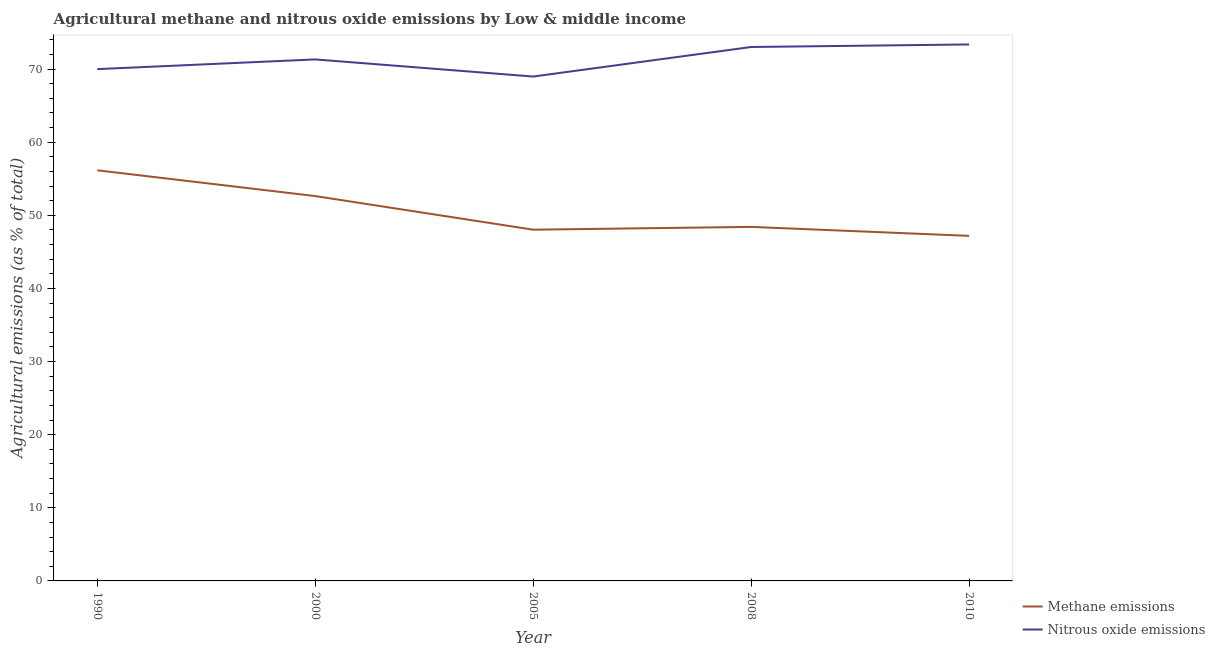How many different coloured lines are there?
Your answer should be very brief. 2. What is the amount of methane emissions in 2000?
Provide a short and direct response. 52.63. Across all years, what is the maximum amount of nitrous oxide emissions?
Ensure brevity in your answer.  73.37. Across all years, what is the minimum amount of methane emissions?
Ensure brevity in your answer.  47.19. What is the total amount of methane emissions in the graph?
Your answer should be very brief. 252.44. What is the difference between the amount of methane emissions in 2008 and that in 2010?
Offer a very short reply. 1.23. What is the difference between the amount of methane emissions in 2008 and the amount of nitrous oxide emissions in 2010?
Give a very brief answer. -24.95. What is the average amount of methane emissions per year?
Keep it short and to the point. 50.49. In the year 2008, what is the difference between the amount of nitrous oxide emissions and amount of methane emissions?
Offer a very short reply. 24.6. In how many years, is the amount of nitrous oxide emissions greater than 48 %?
Your response must be concise. 5. What is the ratio of the amount of methane emissions in 2008 to that in 2010?
Provide a succinct answer. 1.03. What is the difference between the highest and the second highest amount of nitrous oxide emissions?
Make the answer very short. 0.35. What is the difference between the highest and the lowest amount of nitrous oxide emissions?
Provide a short and direct response. 4.39. In how many years, is the amount of nitrous oxide emissions greater than the average amount of nitrous oxide emissions taken over all years?
Ensure brevity in your answer.  2. Does the amount of methane emissions monotonically increase over the years?
Your response must be concise. No. Is the amount of nitrous oxide emissions strictly less than the amount of methane emissions over the years?
Keep it short and to the point. No. How many lines are there?
Provide a short and direct response. 2. How many years are there in the graph?
Provide a succinct answer. 5. Are the values on the major ticks of Y-axis written in scientific E-notation?
Your response must be concise. No. Does the graph contain any zero values?
Your answer should be compact. No. How many legend labels are there?
Your answer should be compact. 2. How are the legend labels stacked?
Give a very brief answer. Vertical. What is the title of the graph?
Provide a succinct answer. Agricultural methane and nitrous oxide emissions by Low & middle income. What is the label or title of the X-axis?
Your response must be concise. Year. What is the label or title of the Y-axis?
Provide a succinct answer. Agricultural emissions (as % of total). What is the Agricultural emissions (as % of total) in Methane emissions in 1990?
Your answer should be compact. 56.16. What is the Agricultural emissions (as % of total) of Nitrous oxide emissions in 1990?
Provide a short and direct response. 70. What is the Agricultural emissions (as % of total) of Methane emissions in 2000?
Make the answer very short. 52.63. What is the Agricultural emissions (as % of total) of Nitrous oxide emissions in 2000?
Make the answer very short. 71.32. What is the Agricultural emissions (as % of total) of Methane emissions in 2005?
Give a very brief answer. 48.04. What is the Agricultural emissions (as % of total) in Nitrous oxide emissions in 2005?
Keep it short and to the point. 68.98. What is the Agricultural emissions (as % of total) in Methane emissions in 2008?
Make the answer very short. 48.42. What is the Agricultural emissions (as % of total) in Nitrous oxide emissions in 2008?
Your answer should be very brief. 73.02. What is the Agricultural emissions (as % of total) in Methane emissions in 2010?
Offer a very short reply. 47.19. What is the Agricultural emissions (as % of total) of Nitrous oxide emissions in 2010?
Provide a short and direct response. 73.37. Across all years, what is the maximum Agricultural emissions (as % of total) in Methane emissions?
Provide a succinct answer. 56.16. Across all years, what is the maximum Agricultural emissions (as % of total) in Nitrous oxide emissions?
Offer a very short reply. 73.37. Across all years, what is the minimum Agricultural emissions (as % of total) in Methane emissions?
Your answer should be very brief. 47.19. Across all years, what is the minimum Agricultural emissions (as % of total) of Nitrous oxide emissions?
Your answer should be compact. 68.98. What is the total Agricultural emissions (as % of total) of Methane emissions in the graph?
Your answer should be very brief. 252.44. What is the total Agricultural emissions (as % of total) in Nitrous oxide emissions in the graph?
Your response must be concise. 356.7. What is the difference between the Agricultural emissions (as % of total) of Methane emissions in 1990 and that in 2000?
Give a very brief answer. 3.52. What is the difference between the Agricultural emissions (as % of total) of Nitrous oxide emissions in 1990 and that in 2000?
Offer a very short reply. -1.33. What is the difference between the Agricultural emissions (as % of total) of Methane emissions in 1990 and that in 2005?
Ensure brevity in your answer.  8.12. What is the difference between the Agricultural emissions (as % of total) in Nitrous oxide emissions in 1990 and that in 2005?
Keep it short and to the point. 1.02. What is the difference between the Agricultural emissions (as % of total) in Methane emissions in 1990 and that in 2008?
Offer a very short reply. 7.74. What is the difference between the Agricultural emissions (as % of total) of Nitrous oxide emissions in 1990 and that in 2008?
Make the answer very short. -3.03. What is the difference between the Agricultural emissions (as % of total) in Methane emissions in 1990 and that in 2010?
Keep it short and to the point. 8.97. What is the difference between the Agricultural emissions (as % of total) in Nitrous oxide emissions in 1990 and that in 2010?
Give a very brief answer. -3.37. What is the difference between the Agricultural emissions (as % of total) in Methane emissions in 2000 and that in 2005?
Give a very brief answer. 4.6. What is the difference between the Agricultural emissions (as % of total) of Nitrous oxide emissions in 2000 and that in 2005?
Provide a short and direct response. 2.34. What is the difference between the Agricultural emissions (as % of total) of Methane emissions in 2000 and that in 2008?
Offer a very short reply. 4.22. What is the difference between the Agricultural emissions (as % of total) of Nitrous oxide emissions in 2000 and that in 2008?
Provide a short and direct response. -1.7. What is the difference between the Agricultural emissions (as % of total) of Methane emissions in 2000 and that in 2010?
Provide a succinct answer. 5.44. What is the difference between the Agricultural emissions (as % of total) of Nitrous oxide emissions in 2000 and that in 2010?
Offer a very short reply. -2.05. What is the difference between the Agricultural emissions (as % of total) of Methane emissions in 2005 and that in 2008?
Give a very brief answer. -0.38. What is the difference between the Agricultural emissions (as % of total) of Nitrous oxide emissions in 2005 and that in 2008?
Your response must be concise. -4.04. What is the difference between the Agricultural emissions (as % of total) of Methane emissions in 2005 and that in 2010?
Ensure brevity in your answer.  0.84. What is the difference between the Agricultural emissions (as % of total) of Nitrous oxide emissions in 2005 and that in 2010?
Make the answer very short. -4.39. What is the difference between the Agricultural emissions (as % of total) of Methane emissions in 2008 and that in 2010?
Make the answer very short. 1.23. What is the difference between the Agricultural emissions (as % of total) of Nitrous oxide emissions in 2008 and that in 2010?
Your response must be concise. -0.35. What is the difference between the Agricultural emissions (as % of total) in Methane emissions in 1990 and the Agricultural emissions (as % of total) in Nitrous oxide emissions in 2000?
Offer a terse response. -15.16. What is the difference between the Agricultural emissions (as % of total) of Methane emissions in 1990 and the Agricultural emissions (as % of total) of Nitrous oxide emissions in 2005?
Provide a short and direct response. -12.82. What is the difference between the Agricultural emissions (as % of total) in Methane emissions in 1990 and the Agricultural emissions (as % of total) in Nitrous oxide emissions in 2008?
Give a very brief answer. -16.86. What is the difference between the Agricultural emissions (as % of total) in Methane emissions in 1990 and the Agricultural emissions (as % of total) in Nitrous oxide emissions in 2010?
Give a very brief answer. -17.21. What is the difference between the Agricultural emissions (as % of total) of Methane emissions in 2000 and the Agricultural emissions (as % of total) of Nitrous oxide emissions in 2005?
Make the answer very short. -16.35. What is the difference between the Agricultural emissions (as % of total) in Methane emissions in 2000 and the Agricultural emissions (as % of total) in Nitrous oxide emissions in 2008?
Your answer should be compact. -20.39. What is the difference between the Agricultural emissions (as % of total) in Methane emissions in 2000 and the Agricultural emissions (as % of total) in Nitrous oxide emissions in 2010?
Your answer should be compact. -20.74. What is the difference between the Agricultural emissions (as % of total) of Methane emissions in 2005 and the Agricultural emissions (as % of total) of Nitrous oxide emissions in 2008?
Offer a very short reply. -24.99. What is the difference between the Agricultural emissions (as % of total) in Methane emissions in 2005 and the Agricultural emissions (as % of total) in Nitrous oxide emissions in 2010?
Your answer should be compact. -25.34. What is the difference between the Agricultural emissions (as % of total) in Methane emissions in 2008 and the Agricultural emissions (as % of total) in Nitrous oxide emissions in 2010?
Your response must be concise. -24.95. What is the average Agricultural emissions (as % of total) in Methane emissions per year?
Your answer should be compact. 50.49. What is the average Agricultural emissions (as % of total) of Nitrous oxide emissions per year?
Ensure brevity in your answer.  71.34. In the year 1990, what is the difference between the Agricultural emissions (as % of total) of Methane emissions and Agricultural emissions (as % of total) of Nitrous oxide emissions?
Offer a very short reply. -13.84. In the year 2000, what is the difference between the Agricultural emissions (as % of total) of Methane emissions and Agricultural emissions (as % of total) of Nitrous oxide emissions?
Ensure brevity in your answer.  -18.69. In the year 2005, what is the difference between the Agricultural emissions (as % of total) in Methane emissions and Agricultural emissions (as % of total) in Nitrous oxide emissions?
Offer a very short reply. -20.95. In the year 2008, what is the difference between the Agricultural emissions (as % of total) of Methane emissions and Agricultural emissions (as % of total) of Nitrous oxide emissions?
Ensure brevity in your answer.  -24.6. In the year 2010, what is the difference between the Agricultural emissions (as % of total) in Methane emissions and Agricultural emissions (as % of total) in Nitrous oxide emissions?
Give a very brief answer. -26.18. What is the ratio of the Agricultural emissions (as % of total) in Methane emissions in 1990 to that in 2000?
Offer a terse response. 1.07. What is the ratio of the Agricultural emissions (as % of total) of Nitrous oxide emissions in 1990 to that in 2000?
Keep it short and to the point. 0.98. What is the ratio of the Agricultural emissions (as % of total) in Methane emissions in 1990 to that in 2005?
Provide a short and direct response. 1.17. What is the ratio of the Agricultural emissions (as % of total) of Nitrous oxide emissions in 1990 to that in 2005?
Offer a terse response. 1.01. What is the ratio of the Agricultural emissions (as % of total) of Methane emissions in 1990 to that in 2008?
Keep it short and to the point. 1.16. What is the ratio of the Agricultural emissions (as % of total) of Nitrous oxide emissions in 1990 to that in 2008?
Give a very brief answer. 0.96. What is the ratio of the Agricultural emissions (as % of total) of Methane emissions in 1990 to that in 2010?
Your answer should be compact. 1.19. What is the ratio of the Agricultural emissions (as % of total) in Nitrous oxide emissions in 1990 to that in 2010?
Provide a short and direct response. 0.95. What is the ratio of the Agricultural emissions (as % of total) in Methane emissions in 2000 to that in 2005?
Provide a short and direct response. 1.1. What is the ratio of the Agricultural emissions (as % of total) of Nitrous oxide emissions in 2000 to that in 2005?
Keep it short and to the point. 1.03. What is the ratio of the Agricultural emissions (as % of total) of Methane emissions in 2000 to that in 2008?
Ensure brevity in your answer.  1.09. What is the ratio of the Agricultural emissions (as % of total) in Nitrous oxide emissions in 2000 to that in 2008?
Your response must be concise. 0.98. What is the ratio of the Agricultural emissions (as % of total) in Methane emissions in 2000 to that in 2010?
Provide a succinct answer. 1.12. What is the ratio of the Agricultural emissions (as % of total) of Nitrous oxide emissions in 2000 to that in 2010?
Give a very brief answer. 0.97. What is the ratio of the Agricultural emissions (as % of total) in Nitrous oxide emissions in 2005 to that in 2008?
Make the answer very short. 0.94. What is the ratio of the Agricultural emissions (as % of total) in Methane emissions in 2005 to that in 2010?
Provide a succinct answer. 1.02. What is the ratio of the Agricultural emissions (as % of total) in Nitrous oxide emissions in 2005 to that in 2010?
Ensure brevity in your answer.  0.94. What is the ratio of the Agricultural emissions (as % of total) of Nitrous oxide emissions in 2008 to that in 2010?
Offer a terse response. 1. What is the difference between the highest and the second highest Agricultural emissions (as % of total) of Methane emissions?
Offer a very short reply. 3.52. What is the difference between the highest and the second highest Agricultural emissions (as % of total) of Nitrous oxide emissions?
Keep it short and to the point. 0.35. What is the difference between the highest and the lowest Agricultural emissions (as % of total) of Methane emissions?
Your response must be concise. 8.97. What is the difference between the highest and the lowest Agricultural emissions (as % of total) in Nitrous oxide emissions?
Keep it short and to the point. 4.39. 